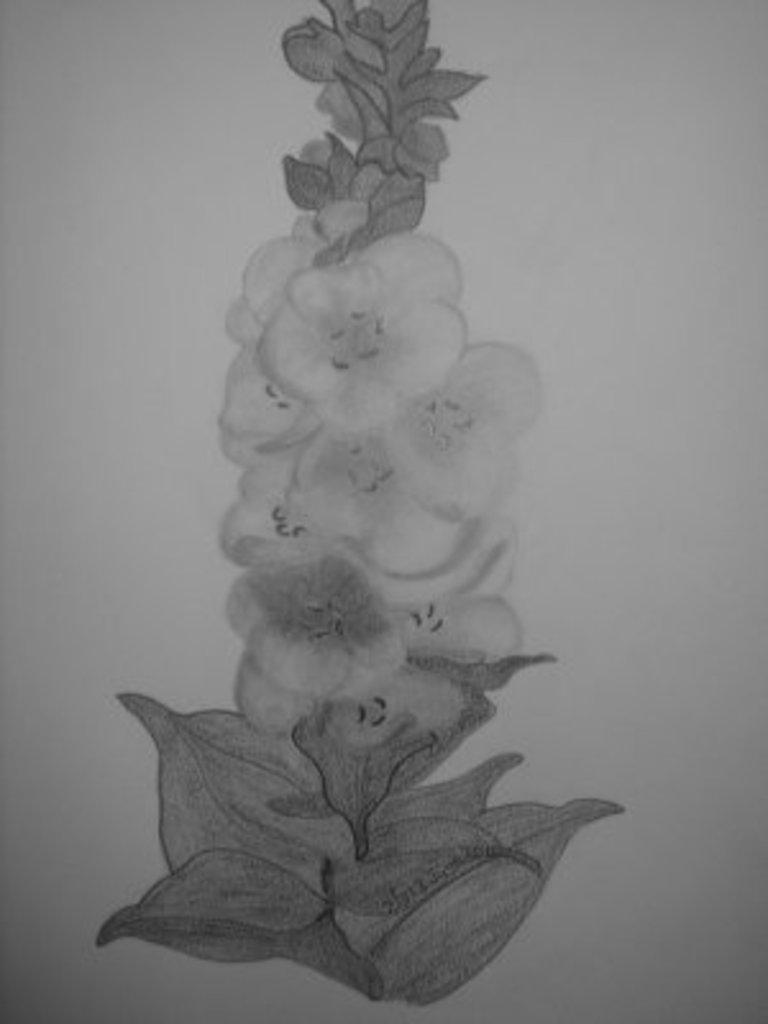What is present on the paper in the image? There is a drawing of a plant on the paper. Can you describe the drawing on the paper? The drawing on the paper is of a plant. Is there a worm smiling in the drawing on the paper? There is no worm present in the drawing on the paper, and therefore no such activity can be observed. 